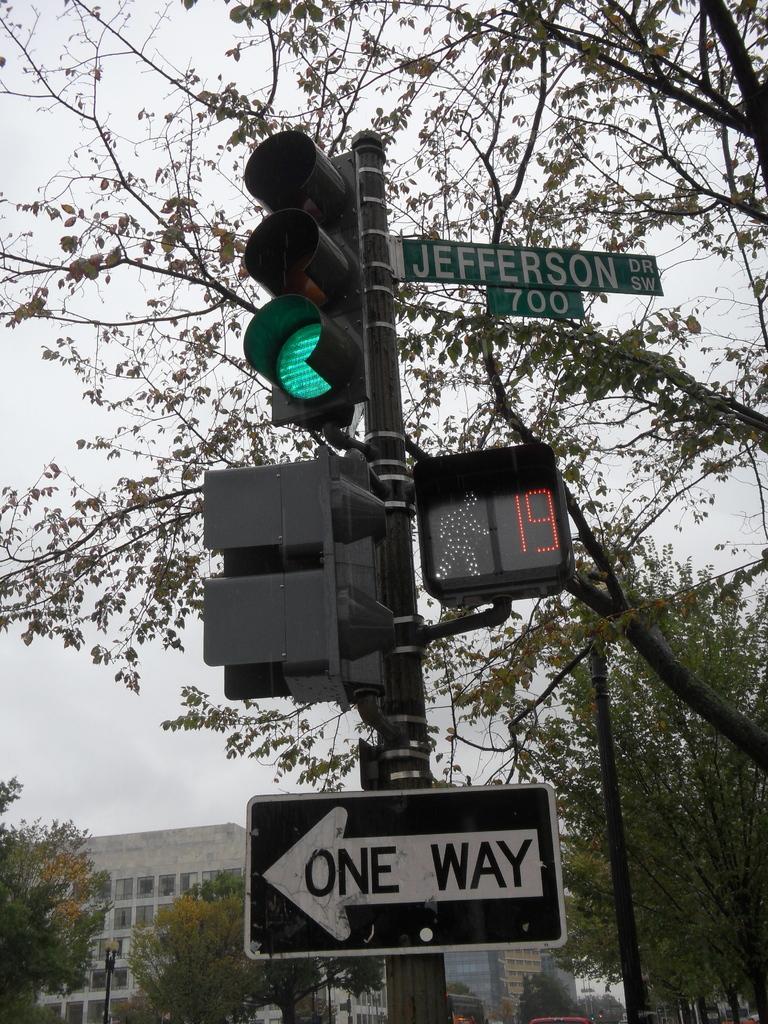What traffic sign direction is given?
Your answer should be compact. One way. 